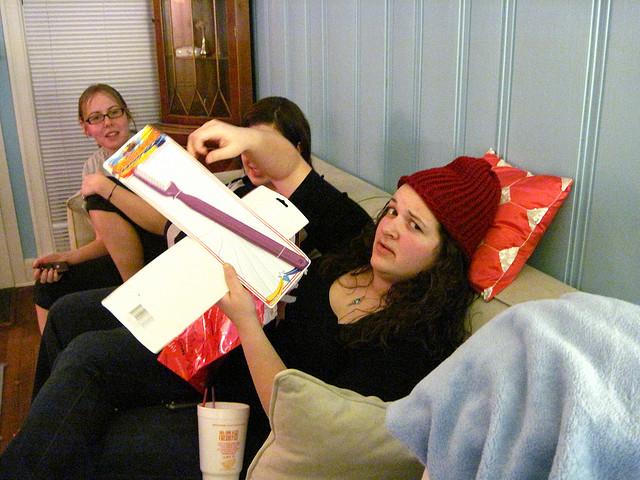Are these all women?
Concise answer only. Yes. What is the girl showing the camera?
Concise answer only. Brush. Where are the women sitting?
Write a very short answer. Couch. 